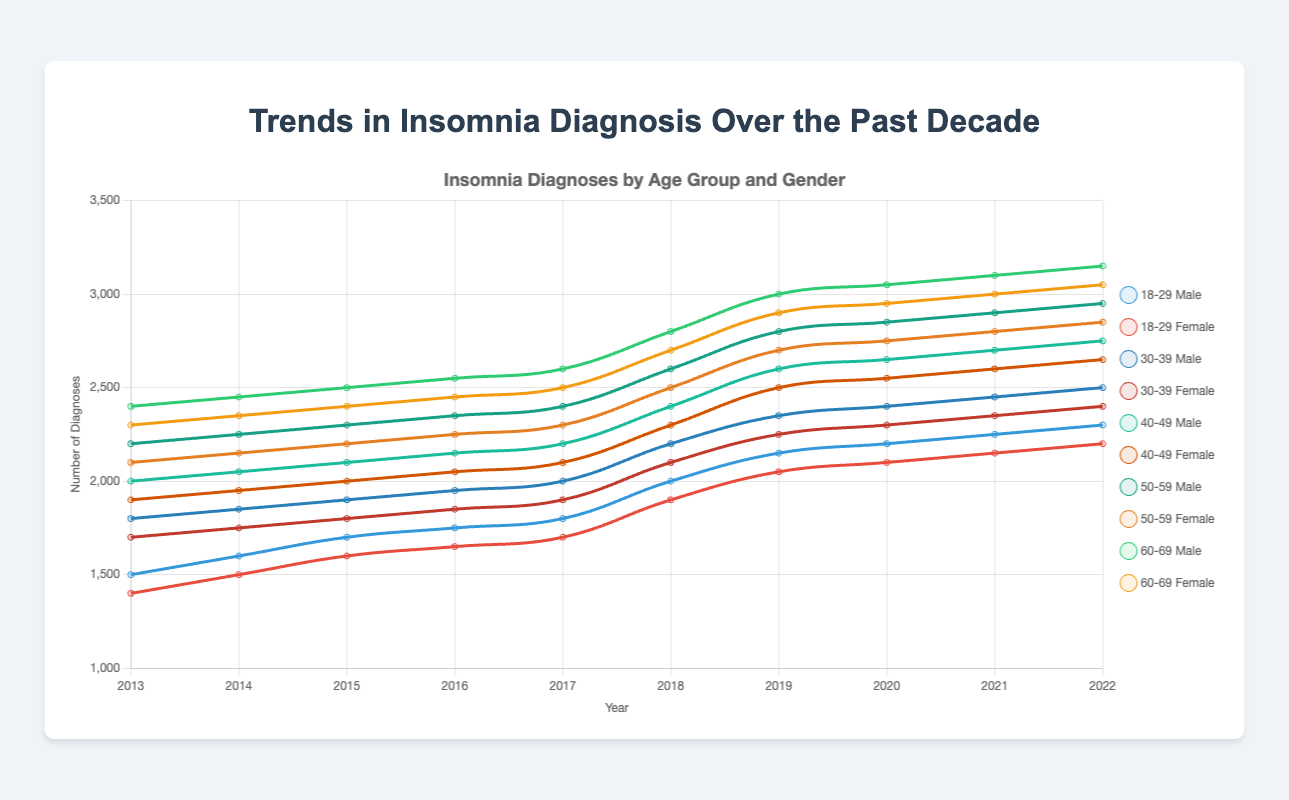Which age group and gender showed the highest number of insomnia diagnoses in 2022? Looking at the endpoint of each line for 2022, the highest number of diagnoses is for Males in the 60-69 age group with 3150 diagnoses.
Answer: Males, 60-69 Which age group consistently had more diagnoses for insomnia from 2013 to 2022, males aged 40-49 or females aged 50-59? By comparing the two lines across all years, you can see that males aged 40-49 consistently had more diagnoses than females aged 50-59.
Answer: Males aged 40-49 Did the number of insomnia diagnoses for females aged 18-29 increase or decrease from 2013 to 2015? By checking the data points from 2013 (1400 diagnoses) to 2015 (1600 diagnoses) for females aged 18-29, it shows an increase.
Answer: Increase Which gender had a greater increase in diagnoses from 2013 to 2022 for the age group 30-39? For males (1800 to 2500) and females (1700 to 2400), both show an increase, but by calculating the difference males increased by 700 while females increased by 700. So the increase is equal.
Answer: Equal Between 2016 and 2019, which age group and gender saw the largest absolute increase in diagnoses? Checking the differences for each group during this period, males aged 50-59 increased from 2350 to 2800, showing an increase of 450, larger than any other group.
Answer: Males, 50-59 What is the average number of diagnoses in 2022 for both genders aged 18-29? Add the 2022 diagnoses for males (2300) and females (2200) aged 18-29. The sum is 4500, and the average is 4500/2 = 2250.
Answer: 2250 For the years 2020 to 2022, which age group and gender saw the smallest increase in diagnoses? Calculate the increase for each age group and gender from 2020 to 2022. For males and females aged 30-39, the increases are from 2400 to 2500 (100) and 2300 to 2400 (100) respectively, which are the smallest increases.
Answer: Both Males and Females aged 30-39 Did any age group and gender have a consistent rise in diagnoses every single year from 2013 to 2022? By reviewing the lines, the males aged 50-59 consistently show a rising trend each year from 2013 to 2022 without any dips.
Answer: Males aged 50-59 Comparing 2019 and 2021, which gender had a higher count of insomnia diagnoses in the age group 40-49? For 2019, males had 2600 and females had 2500, while for 2021, males had 2700 and females had 2600. In both years, males had higher counts.
Answer: Males 